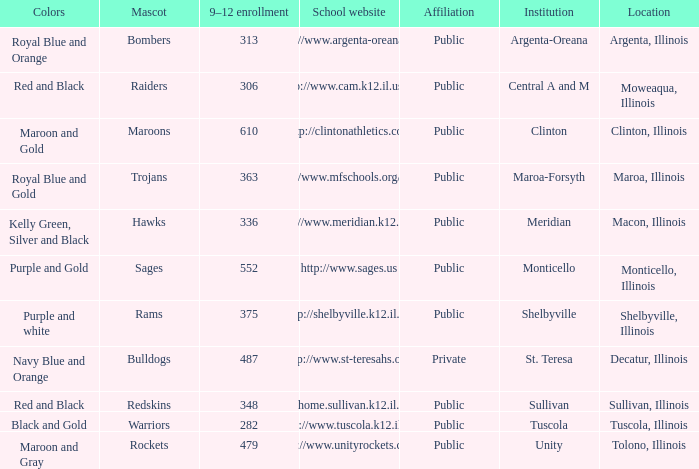What's the name of the city or town of the school that operates the http://www.mfschools.org/high/ website? Maroa-Forsyth. 